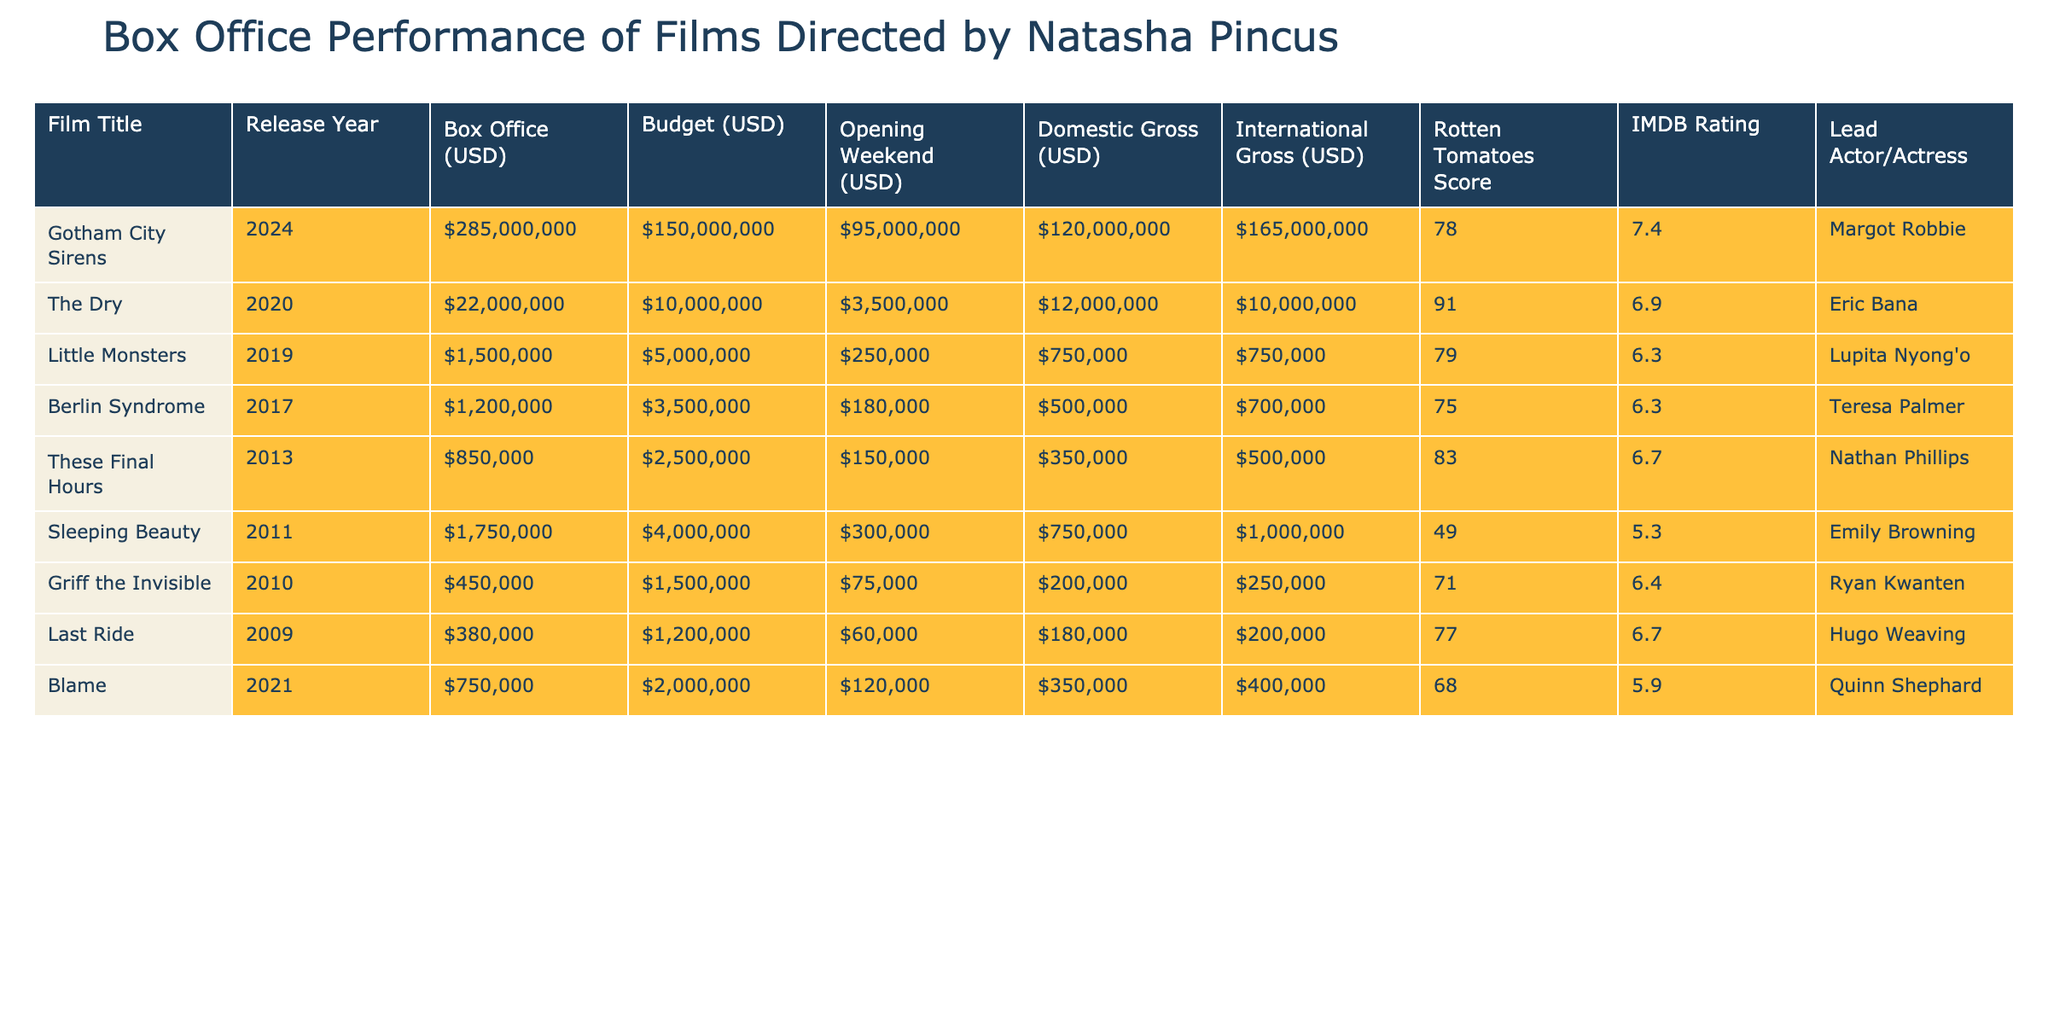What is the box office gross for "The Dry"? The box office gross for "The Dry" is listed as $22,000,000 in the table.
Answer: $22,000,000 Which film had the highest Rotten Tomatoes score? Examining the Rotten Tomatoes scores, "The Dry" has the highest score of 91.
Answer: "The Dry" What is the total box office gross for all films directed by Natasha Pincus? To find the total box office gross, we sum the individual box office grosses: 285,000,000 + 22,000,000 + 1,500,000 + 1,200,000 + 850,000 + 1,750,000 + 450,000 + 380,000 + 750,000 = 313,380,000.
Answer: $313,380,000 How much did "Gotham City Sirens" earn during its opening weekend? According to the table, "Gotham City Sirens" earned $95,000,000 during its opening weekend.
Answer: $95,000,000 Did "Sleeping Beauty" have a higher domestic gross than "Little Monsters"? "Sleeping Beauty" has a domestic gross of $750,000, while "Little Monsters" has $750,000 as well; thus, they are equal.
Answer: No Which film had the lowest budget and what was it? "Griff the Invisible" had the lowest budget listed, which is $1,500,000.
Answer: $1,500,000 What is the average IMDB rating of the films listed? The total sum of the IMDB ratings is 7.4 + 6.9 + 6.3 + 6.3 + 6.7 + 5.3 + 6.4 + 6.7 + 5.9 = 56.5. There are 9 films, so the average is 56.5 / 9 = 6.28.
Answer: 6.28 Which film had the biggest difference between its budget and box office gross? Calculating the differences: "Gotham City Sirens" ($285,000,000 - $150,000,000 = $135,000,000), "The Dry" ($22,000,000 - $10,000,000 = $12,000,000), etc. The highest difference is from "Gotham City Sirens" at $135,000,000.
Answer: "Gotham City Sirens" Is it true that all films directed by Natasha Pincus earned over $1 million at the box office? "Griff the Invisible" and "Last Ride" both earned less than $1 million at the box office, making the statement false.
Answer: No What was the combined international gross of "Blame" and "Berlin Syndrome"? Adding the international grosses gives: "Blame" ($400,000) + "Berlin Syndrome" ($700,000) = $1,100,000 combined international gross.
Answer: $1,100,000 